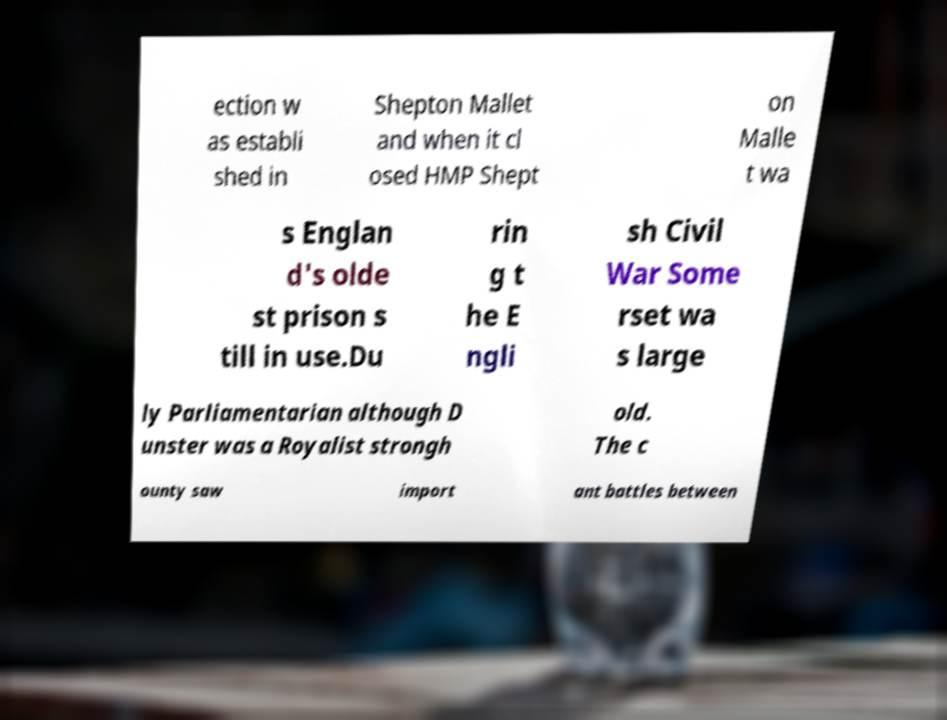Please read and relay the text visible in this image. What does it say? ection w as establi shed in Shepton Mallet and when it cl osed HMP Shept on Malle t wa s Englan d's olde st prison s till in use.Du rin g t he E ngli sh Civil War Some rset wa s large ly Parliamentarian although D unster was a Royalist strongh old. The c ounty saw import ant battles between 